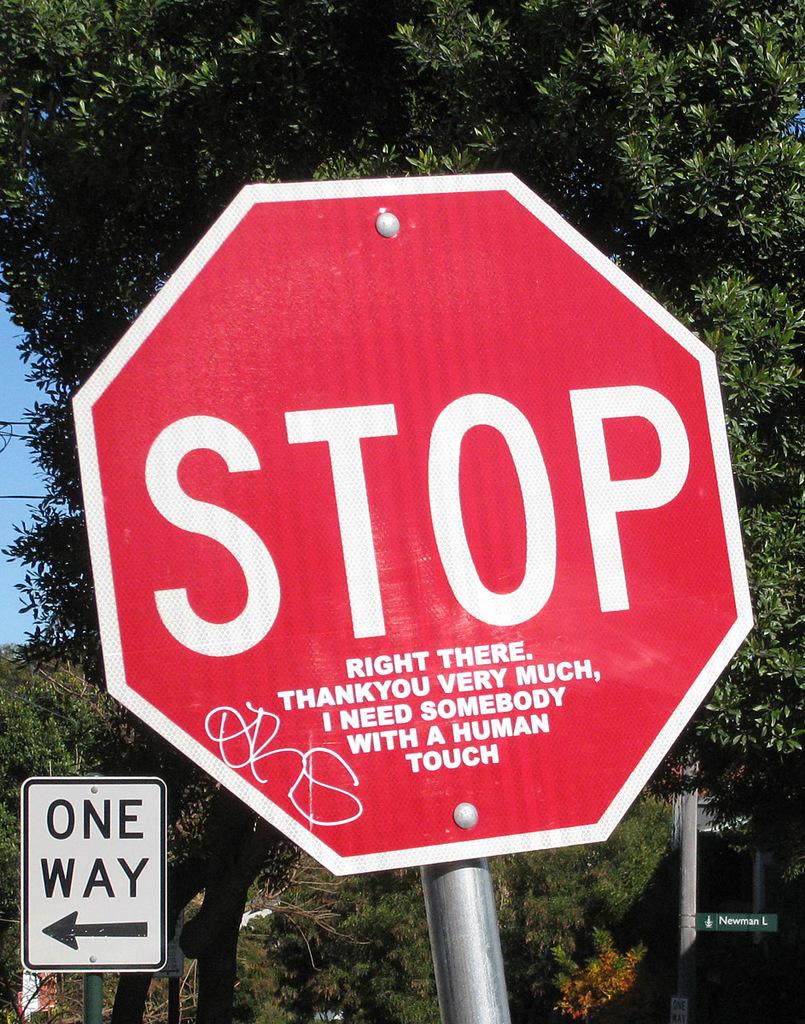I need somebody with a what?
Make the answer very short. Human touch. What kind of signs are in this photo>?
Make the answer very short. Stop. 